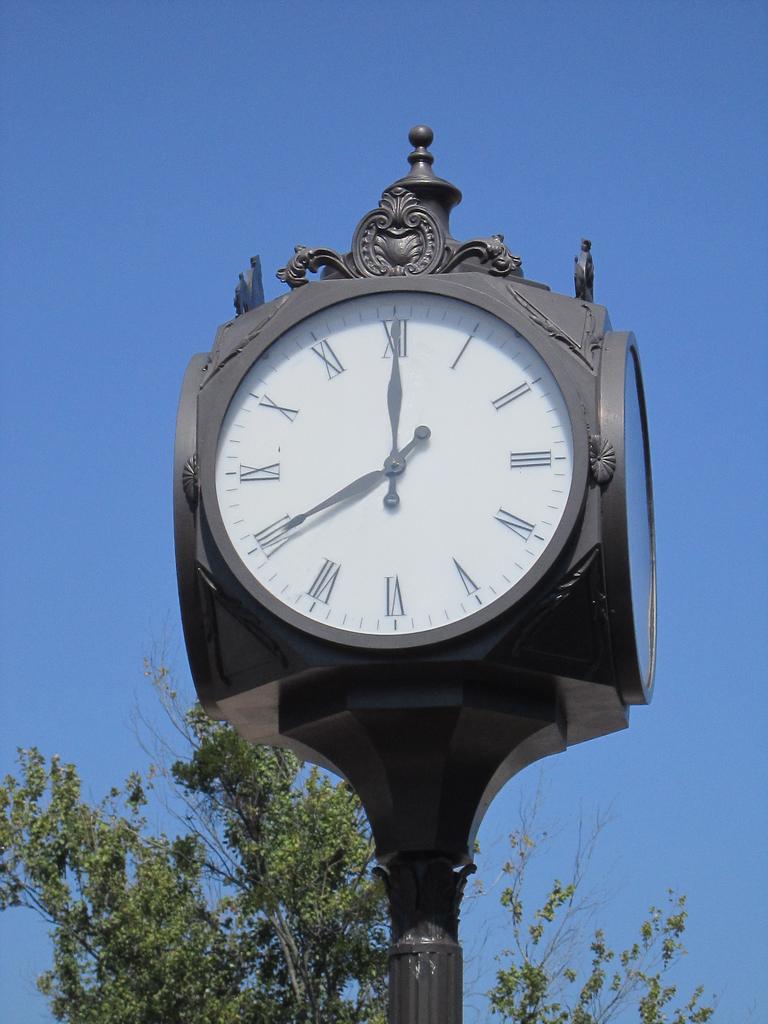What time is it?
Offer a terse response. 8:00. 